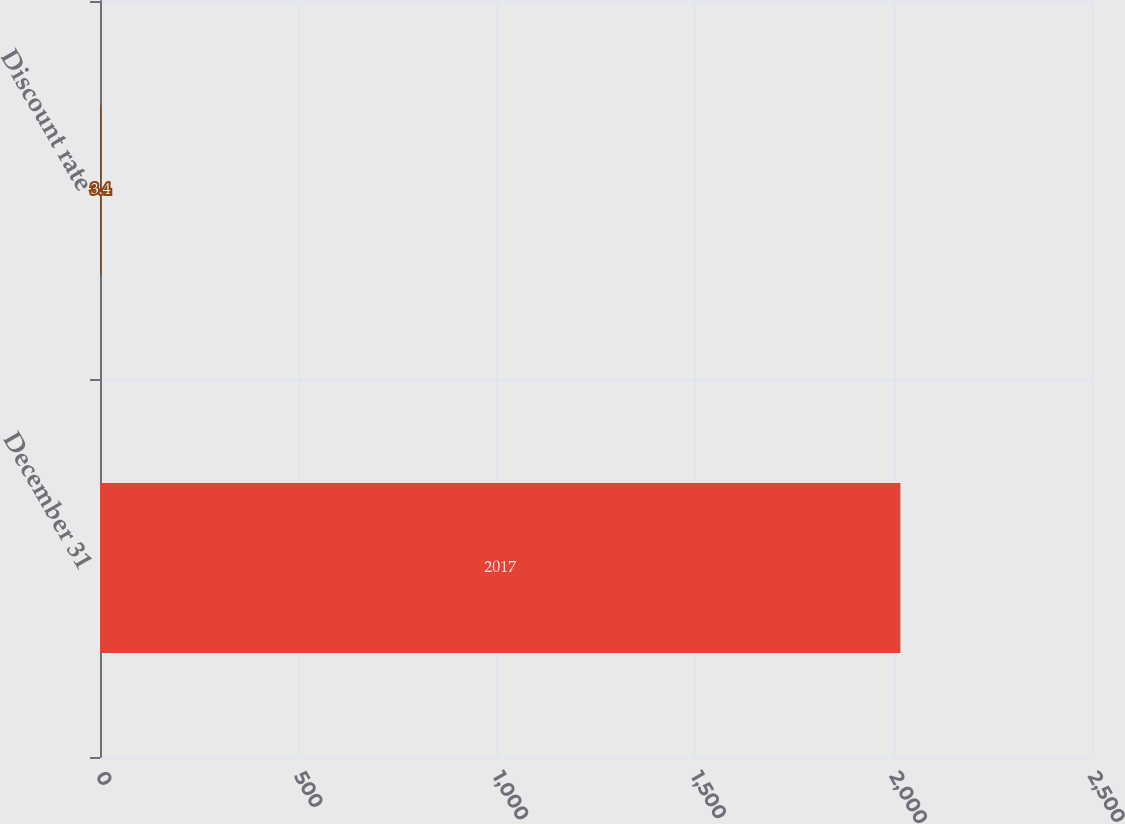Convert chart. <chart><loc_0><loc_0><loc_500><loc_500><bar_chart><fcel>December 31<fcel>Discount rate<nl><fcel>2017<fcel>3.4<nl></chart> 